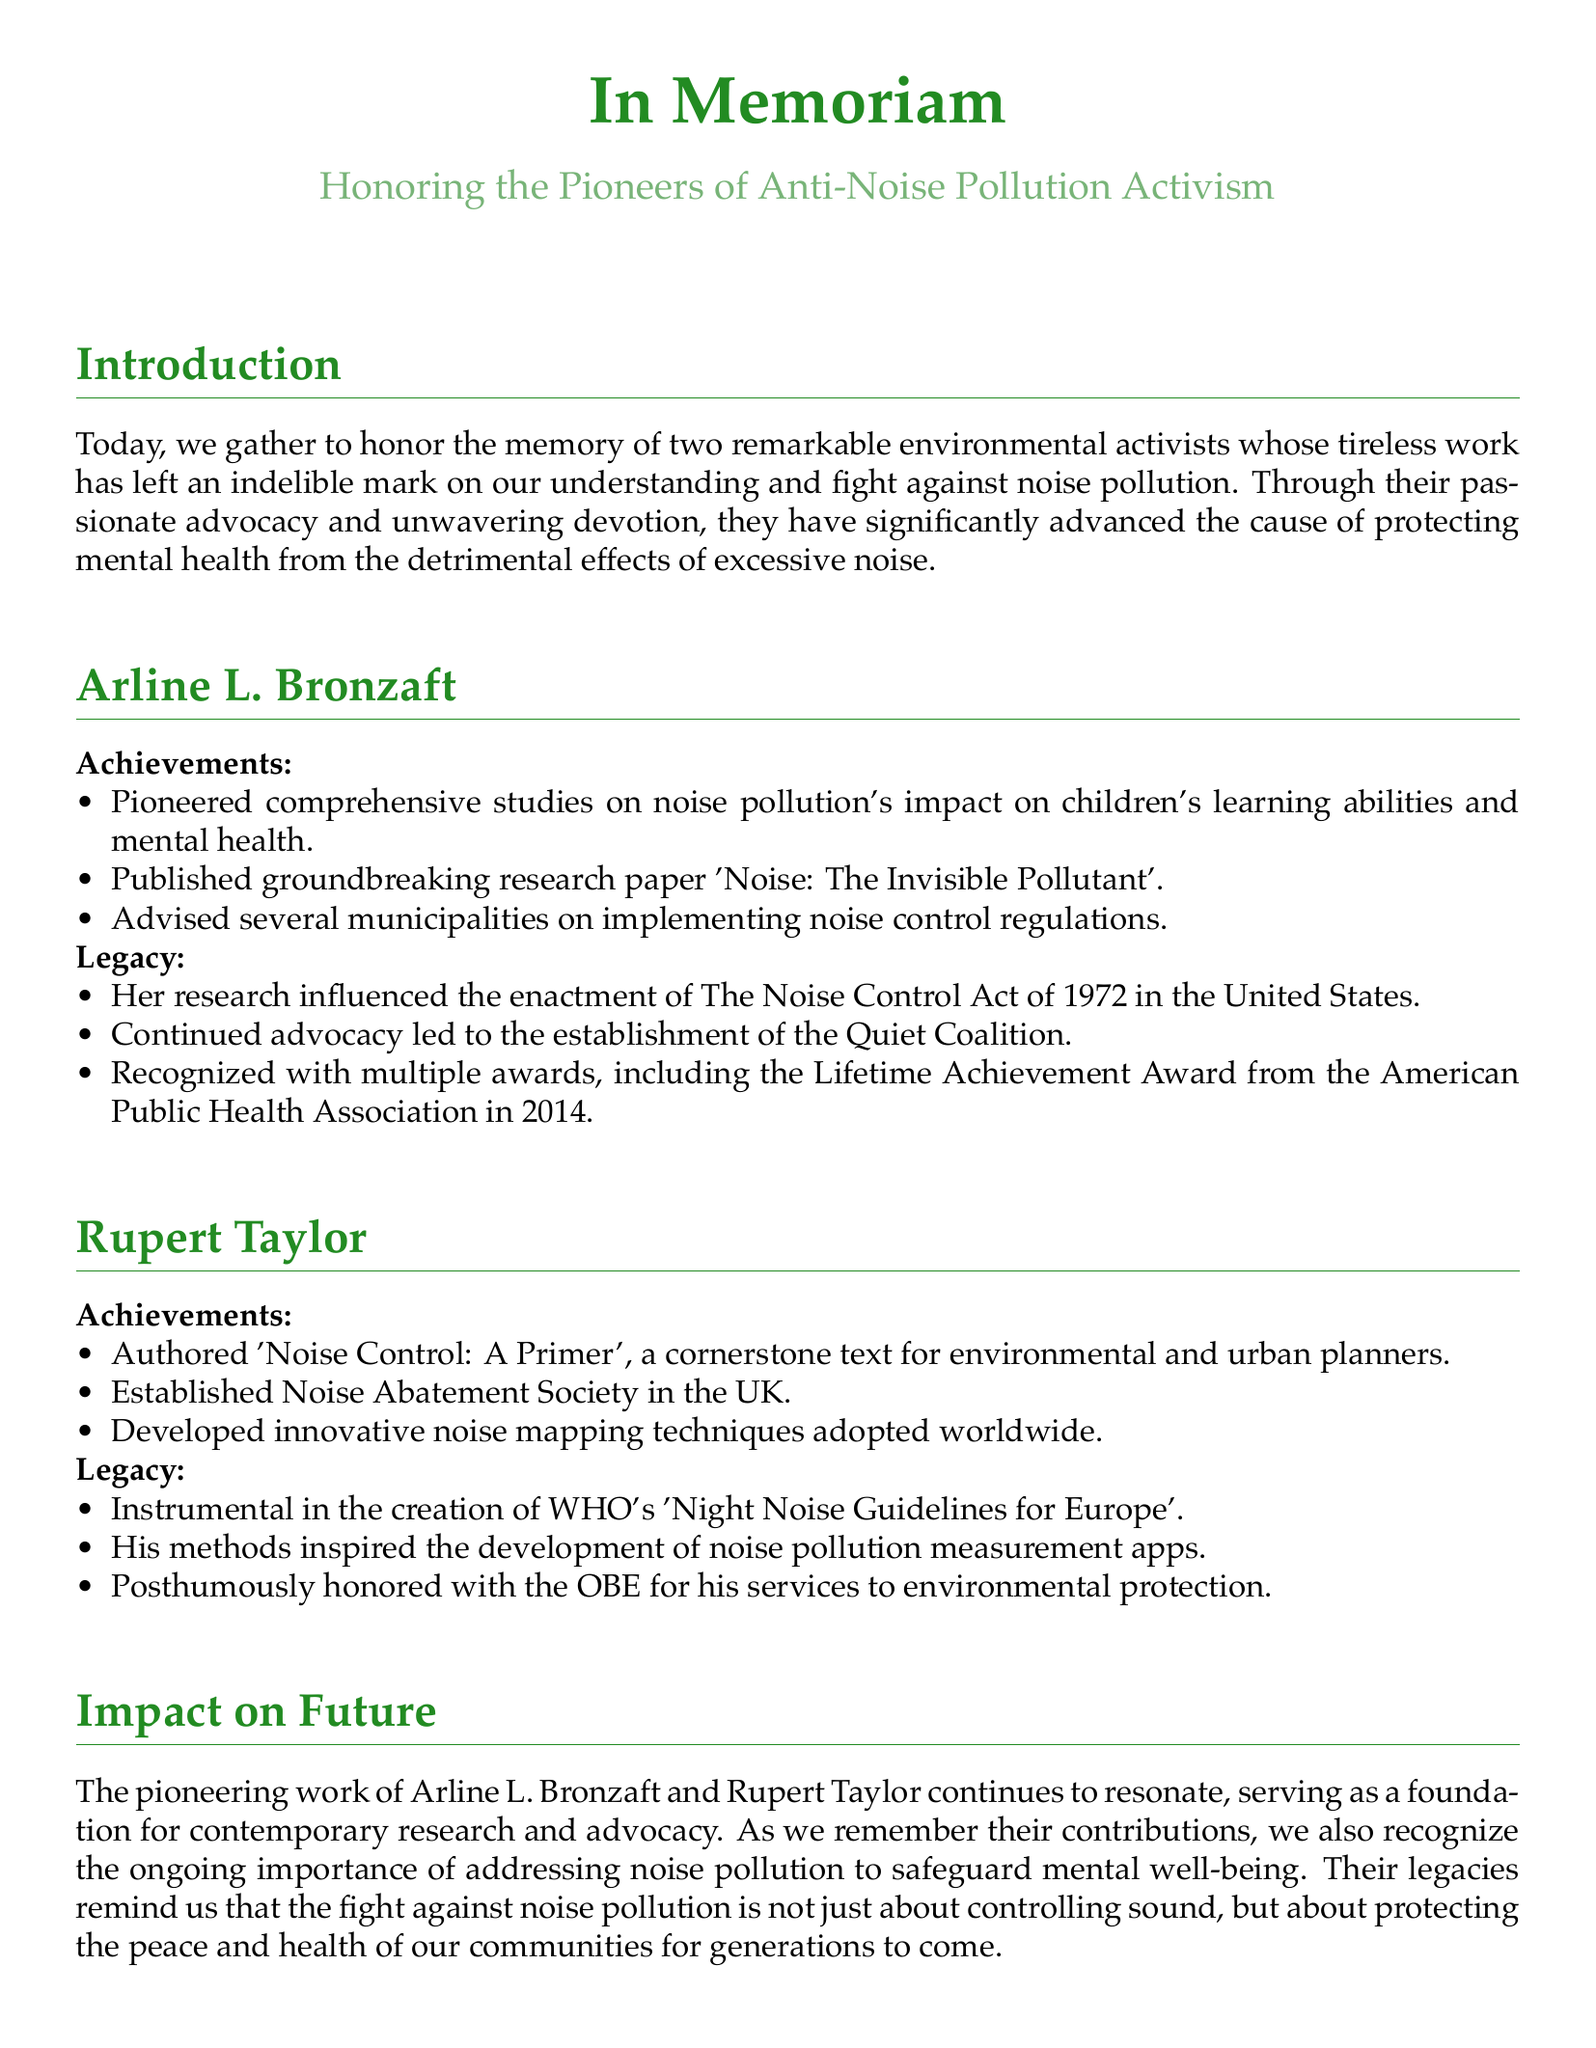what is the title of Arline L. Bronzaft's groundbreaking research paper? The title of her research paper is 'Noise: The Invisible Pollutant'.
Answer: 'Noise: The Invisible Pollutant' what year was the Lifetime Achievement Award given to Arline L. Bronzaft? The award was given in 2014.
Answer: 2014 who established the Noise Abatement Society in the UK? The Noise Abatement Society was established by Rupert Taylor.
Answer: Rupert Taylor what significant act did Arline L. Bronzaft's research influence? Her research influenced the enactment of The Noise Control Act of 1972.
Answer: The Noise Control Act of 1972 which organization's guidelines did Rupert Taylor help create? He was instrumental in the creation of WHO's guidelines.
Answer: WHO what did Rupert Taylor author that is a cornerstone text for planners? He authored 'Noise Control: A Primer'.
Answer: 'Noise Control: A Primer' how did the impact of Bronzaft and Taylor's work resonate in future efforts? Their work serves as a foundation for contemporary research and advocacy.
Answer: Foundation for contemporary research and advocacy what is the defining theme of the eulogy's concluding remark? The theme emphasizes a commitment to combating noise pollution.
Answer: Commitment to combating noise pollution 